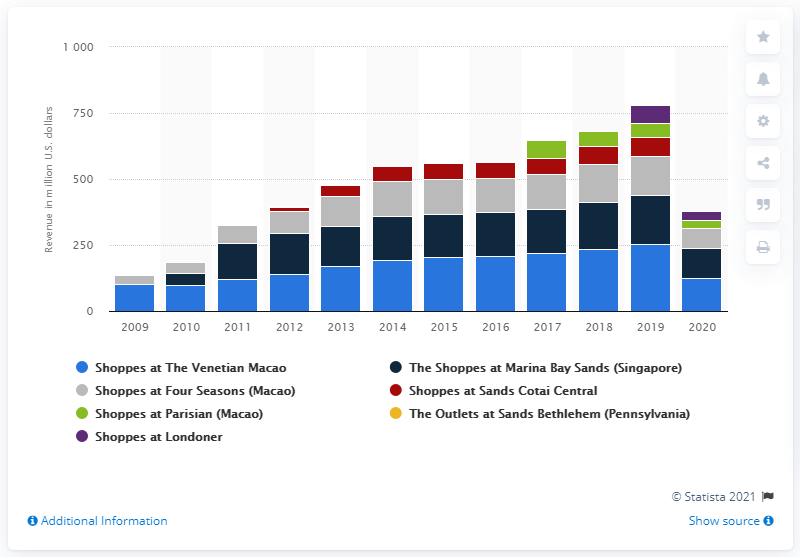Highlight a few significant elements in this photo. In 2020, the revenue generated by The Shoppes at The Venetian in Macao was approximately 125 million. 